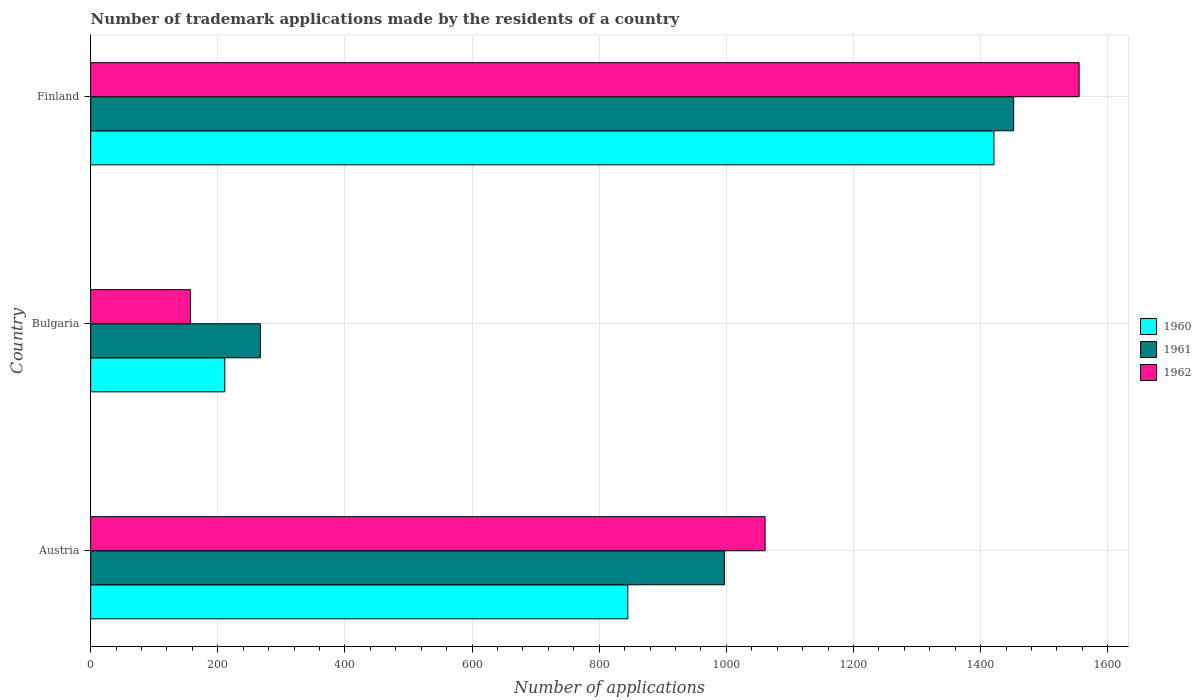How many different coloured bars are there?
Offer a terse response. 3. Are the number of bars on each tick of the Y-axis equal?
Your answer should be very brief. Yes. How many bars are there on the 1st tick from the top?
Offer a terse response. 3. In how many cases, is the number of bars for a given country not equal to the number of legend labels?
Your answer should be very brief. 0. What is the number of trademark applications made by the residents in 1960 in Austria?
Your response must be concise. 845. Across all countries, what is the maximum number of trademark applications made by the residents in 1960?
Offer a very short reply. 1421. Across all countries, what is the minimum number of trademark applications made by the residents in 1962?
Make the answer very short. 157. In which country was the number of trademark applications made by the residents in 1962 maximum?
Your answer should be compact. Finland. What is the total number of trademark applications made by the residents in 1962 in the graph?
Your answer should be very brief. 2773. What is the difference between the number of trademark applications made by the residents in 1960 in Bulgaria and that in Finland?
Offer a terse response. -1210. What is the difference between the number of trademark applications made by the residents in 1961 in Bulgaria and the number of trademark applications made by the residents in 1960 in Finland?
Ensure brevity in your answer.  -1154. What is the average number of trademark applications made by the residents in 1962 per country?
Provide a succinct answer. 924.33. What is the difference between the number of trademark applications made by the residents in 1962 and number of trademark applications made by the residents in 1960 in Finland?
Your answer should be compact. 134. What is the ratio of the number of trademark applications made by the residents in 1961 in Austria to that in Bulgaria?
Your answer should be very brief. 3.73. Is the number of trademark applications made by the residents in 1960 in Bulgaria less than that in Finland?
Your answer should be very brief. Yes. Is the difference between the number of trademark applications made by the residents in 1962 in Bulgaria and Finland greater than the difference between the number of trademark applications made by the residents in 1960 in Bulgaria and Finland?
Your answer should be compact. No. What is the difference between the highest and the second highest number of trademark applications made by the residents in 1960?
Provide a succinct answer. 576. What is the difference between the highest and the lowest number of trademark applications made by the residents in 1960?
Your answer should be very brief. 1210. In how many countries, is the number of trademark applications made by the residents in 1960 greater than the average number of trademark applications made by the residents in 1960 taken over all countries?
Keep it short and to the point. 2. Is the sum of the number of trademark applications made by the residents in 1962 in Austria and Finland greater than the maximum number of trademark applications made by the residents in 1961 across all countries?
Keep it short and to the point. Yes. What does the 3rd bar from the top in Austria represents?
Your response must be concise. 1960. Are all the bars in the graph horizontal?
Your answer should be compact. Yes. What is the difference between two consecutive major ticks on the X-axis?
Provide a short and direct response. 200. Are the values on the major ticks of X-axis written in scientific E-notation?
Offer a terse response. No. Does the graph contain grids?
Offer a very short reply. Yes. How many legend labels are there?
Ensure brevity in your answer.  3. How are the legend labels stacked?
Provide a short and direct response. Vertical. What is the title of the graph?
Your answer should be very brief. Number of trademark applications made by the residents of a country. What is the label or title of the X-axis?
Provide a short and direct response. Number of applications. What is the Number of applications in 1960 in Austria?
Offer a very short reply. 845. What is the Number of applications in 1961 in Austria?
Your answer should be compact. 997. What is the Number of applications in 1962 in Austria?
Give a very brief answer. 1061. What is the Number of applications in 1960 in Bulgaria?
Provide a short and direct response. 211. What is the Number of applications of 1961 in Bulgaria?
Ensure brevity in your answer.  267. What is the Number of applications of 1962 in Bulgaria?
Your answer should be compact. 157. What is the Number of applications of 1960 in Finland?
Provide a succinct answer. 1421. What is the Number of applications of 1961 in Finland?
Ensure brevity in your answer.  1452. What is the Number of applications of 1962 in Finland?
Make the answer very short. 1555. Across all countries, what is the maximum Number of applications of 1960?
Your answer should be very brief. 1421. Across all countries, what is the maximum Number of applications in 1961?
Make the answer very short. 1452. Across all countries, what is the maximum Number of applications of 1962?
Keep it short and to the point. 1555. Across all countries, what is the minimum Number of applications in 1960?
Your response must be concise. 211. Across all countries, what is the minimum Number of applications in 1961?
Offer a terse response. 267. Across all countries, what is the minimum Number of applications of 1962?
Your answer should be very brief. 157. What is the total Number of applications in 1960 in the graph?
Ensure brevity in your answer.  2477. What is the total Number of applications of 1961 in the graph?
Make the answer very short. 2716. What is the total Number of applications of 1962 in the graph?
Your response must be concise. 2773. What is the difference between the Number of applications of 1960 in Austria and that in Bulgaria?
Ensure brevity in your answer.  634. What is the difference between the Number of applications of 1961 in Austria and that in Bulgaria?
Give a very brief answer. 730. What is the difference between the Number of applications in 1962 in Austria and that in Bulgaria?
Keep it short and to the point. 904. What is the difference between the Number of applications in 1960 in Austria and that in Finland?
Keep it short and to the point. -576. What is the difference between the Number of applications of 1961 in Austria and that in Finland?
Make the answer very short. -455. What is the difference between the Number of applications of 1962 in Austria and that in Finland?
Offer a very short reply. -494. What is the difference between the Number of applications in 1960 in Bulgaria and that in Finland?
Provide a short and direct response. -1210. What is the difference between the Number of applications in 1961 in Bulgaria and that in Finland?
Keep it short and to the point. -1185. What is the difference between the Number of applications in 1962 in Bulgaria and that in Finland?
Offer a very short reply. -1398. What is the difference between the Number of applications of 1960 in Austria and the Number of applications of 1961 in Bulgaria?
Make the answer very short. 578. What is the difference between the Number of applications of 1960 in Austria and the Number of applications of 1962 in Bulgaria?
Provide a short and direct response. 688. What is the difference between the Number of applications in 1961 in Austria and the Number of applications in 1962 in Bulgaria?
Keep it short and to the point. 840. What is the difference between the Number of applications of 1960 in Austria and the Number of applications of 1961 in Finland?
Provide a short and direct response. -607. What is the difference between the Number of applications of 1960 in Austria and the Number of applications of 1962 in Finland?
Your answer should be very brief. -710. What is the difference between the Number of applications in 1961 in Austria and the Number of applications in 1962 in Finland?
Offer a very short reply. -558. What is the difference between the Number of applications of 1960 in Bulgaria and the Number of applications of 1961 in Finland?
Provide a short and direct response. -1241. What is the difference between the Number of applications of 1960 in Bulgaria and the Number of applications of 1962 in Finland?
Ensure brevity in your answer.  -1344. What is the difference between the Number of applications of 1961 in Bulgaria and the Number of applications of 1962 in Finland?
Ensure brevity in your answer.  -1288. What is the average Number of applications of 1960 per country?
Your answer should be compact. 825.67. What is the average Number of applications in 1961 per country?
Provide a succinct answer. 905.33. What is the average Number of applications of 1962 per country?
Your response must be concise. 924.33. What is the difference between the Number of applications of 1960 and Number of applications of 1961 in Austria?
Give a very brief answer. -152. What is the difference between the Number of applications in 1960 and Number of applications in 1962 in Austria?
Give a very brief answer. -216. What is the difference between the Number of applications in 1961 and Number of applications in 1962 in Austria?
Give a very brief answer. -64. What is the difference between the Number of applications of 1960 and Number of applications of 1961 in Bulgaria?
Offer a terse response. -56. What is the difference between the Number of applications in 1960 and Number of applications in 1962 in Bulgaria?
Provide a short and direct response. 54. What is the difference between the Number of applications in 1961 and Number of applications in 1962 in Bulgaria?
Keep it short and to the point. 110. What is the difference between the Number of applications in 1960 and Number of applications in 1961 in Finland?
Your answer should be compact. -31. What is the difference between the Number of applications in 1960 and Number of applications in 1962 in Finland?
Keep it short and to the point. -134. What is the difference between the Number of applications of 1961 and Number of applications of 1962 in Finland?
Provide a short and direct response. -103. What is the ratio of the Number of applications in 1960 in Austria to that in Bulgaria?
Your response must be concise. 4. What is the ratio of the Number of applications in 1961 in Austria to that in Bulgaria?
Provide a succinct answer. 3.73. What is the ratio of the Number of applications of 1962 in Austria to that in Bulgaria?
Make the answer very short. 6.76. What is the ratio of the Number of applications of 1960 in Austria to that in Finland?
Your answer should be very brief. 0.59. What is the ratio of the Number of applications in 1961 in Austria to that in Finland?
Provide a succinct answer. 0.69. What is the ratio of the Number of applications of 1962 in Austria to that in Finland?
Offer a terse response. 0.68. What is the ratio of the Number of applications in 1960 in Bulgaria to that in Finland?
Ensure brevity in your answer.  0.15. What is the ratio of the Number of applications in 1961 in Bulgaria to that in Finland?
Ensure brevity in your answer.  0.18. What is the ratio of the Number of applications in 1962 in Bulgaria to that in Finland?
Give a very brief answer. 0.1. What is the difference between the highest and the second highest Number of applications of 1960?
Offer a very short reply. 576. What is the difference between the highest and the second highest Number of applications of 1961?
Make the answer very short. 455. What is the difference between the highest and the second highest Number of applications of 1962?
Your answer should be very brief. 494. What is the difference between the highest and the lowest Number of applications of 1960?
Offer a terse response. 1210. What is the difference between the highest and the lowest Number of applications of 1961?
Ensure brevity in your answer.  1185. What is the difference between the highest and the lowest Number of applications of 1962?
Provide a short and direct response. 1398. 